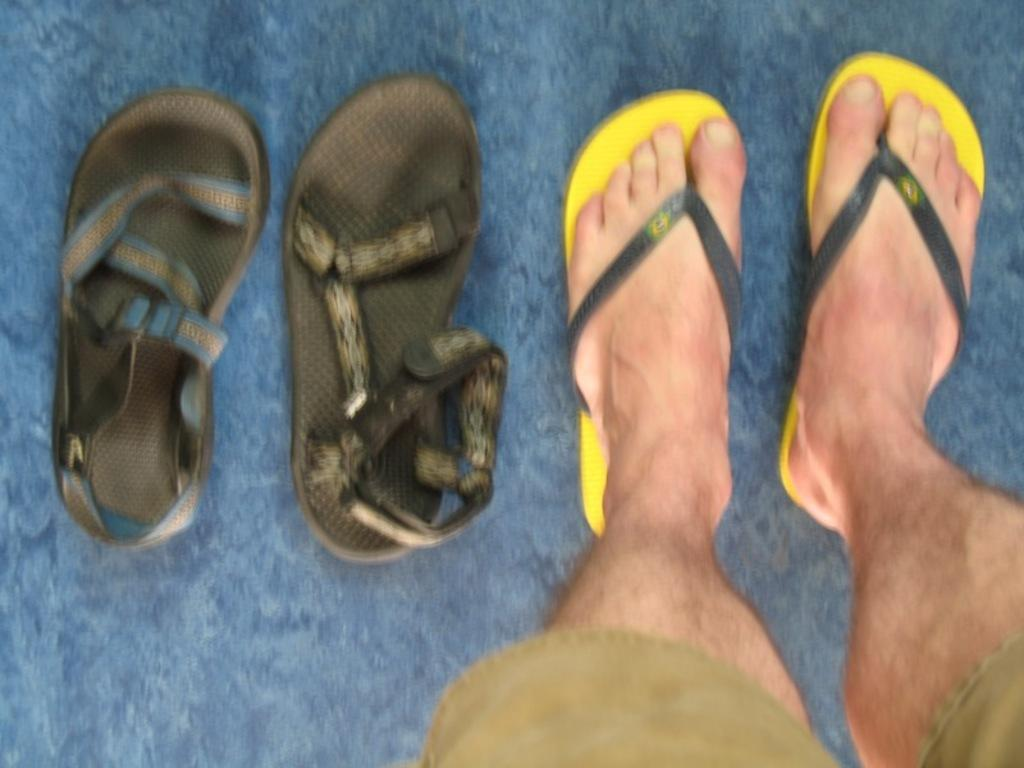Who is present in the image? There is a man in the image. What type of footwear is the man wearing? The man is wearing slippers. What type of footwear is visible on the left side of the image? There are sandals on the left side of the image. What is on the floor in the image? There is a floor mat on the floor in the image. What type of spade is the man using in the image? There is no spade present in the image. Where is the park located in the image? There is no park present in the image. 